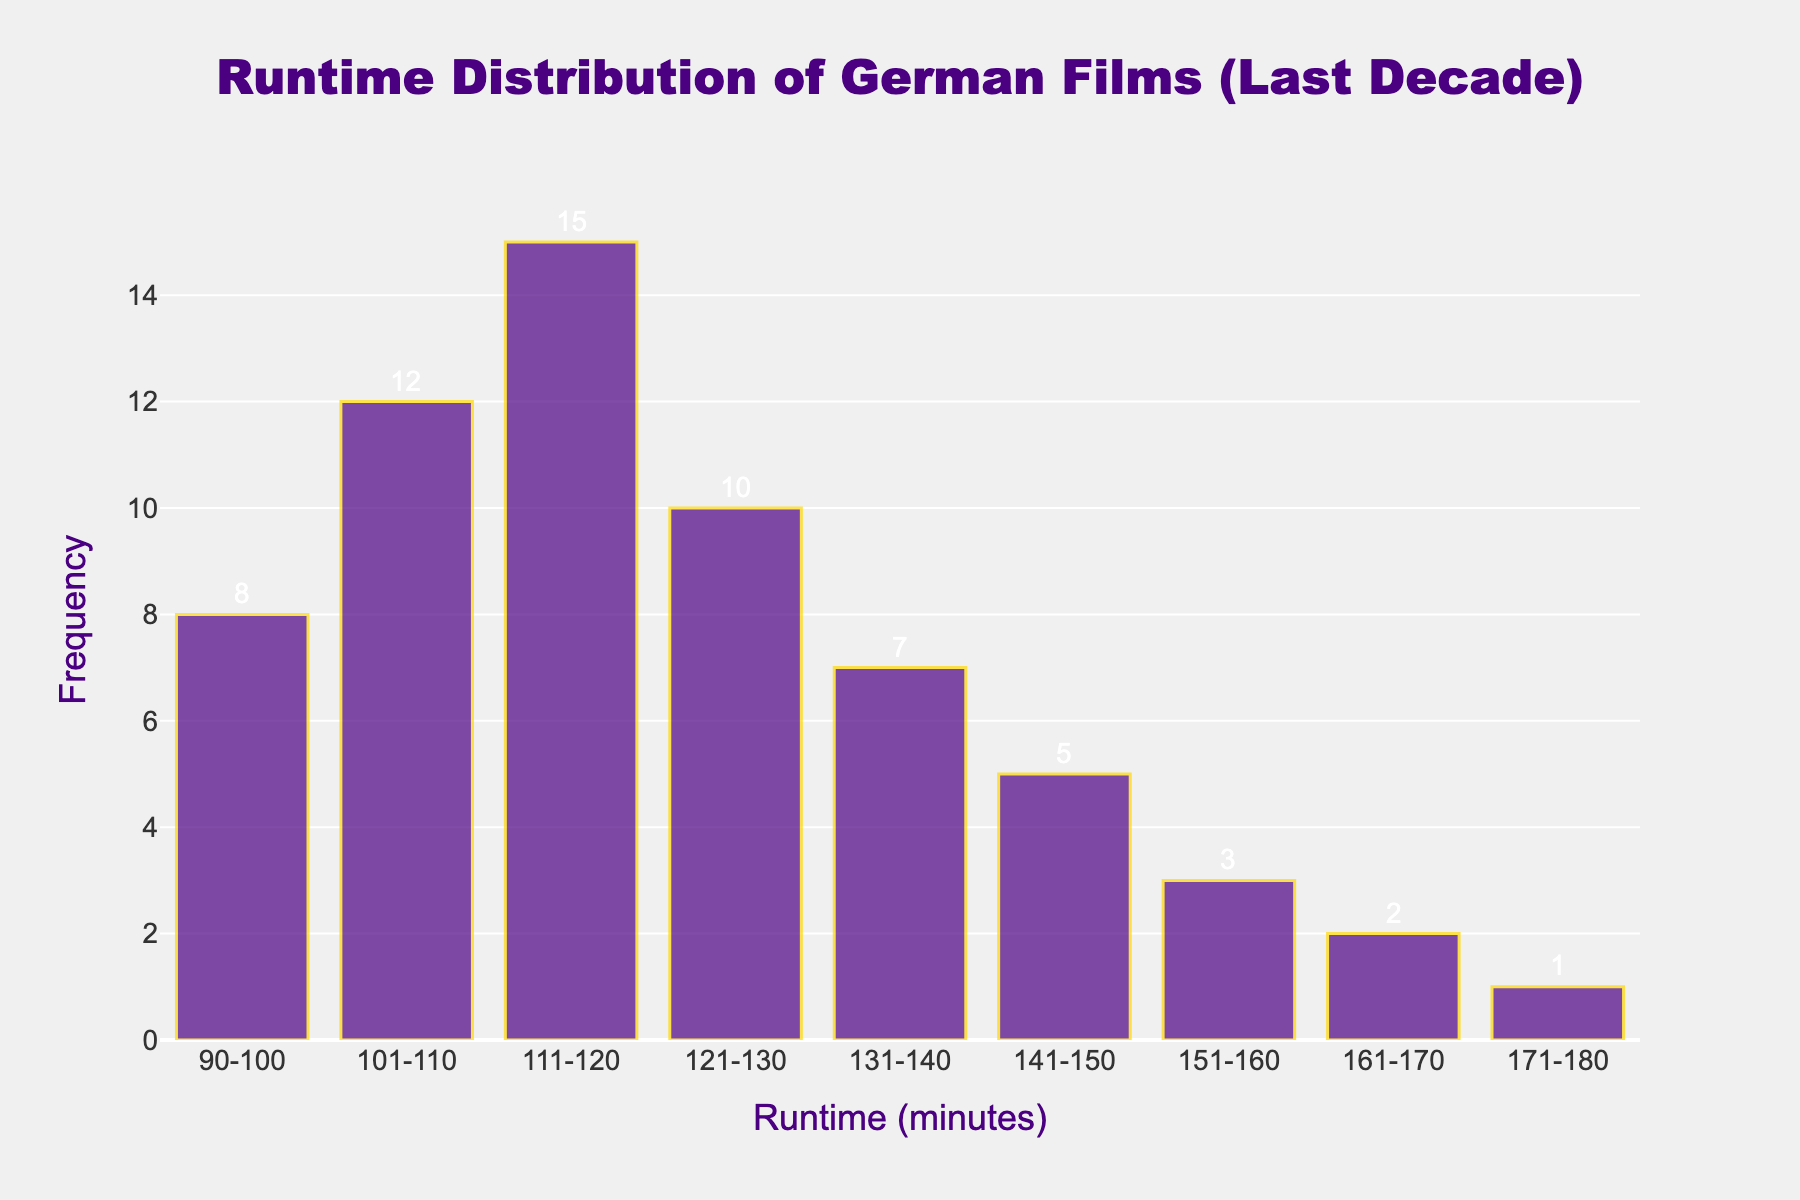What is the title of the histogram? The title of the histogram is displayed at the top center of the figure. It reads "Runtime Distribution of German Films (Last Decade)".
Answer: Runtime Distribution of German Films (Last Decade) What is the color of the bars in the histogram? The bars in the histogram are colored indigo.
Answer: Indigo What is the most frequent runtime range for German films? The highest bar in the histogram represents the most frequent runtime range. The bar with the highest frequency is in the 111-120 minutes range, which has a frequency of 15.
Answer: 111-120 minutes How many runtime ranges have a frequency of more than 10? By examining the bars, we find that the ranges 101-110 minutes (12) and 111-120 minutes (15) have frequencies greater than 10.
Answer: 2 What is the least frequent runtime range for German films? The bar with the lowest height represents the least frequent runtime range. The range 171-180 minutes has a frequency of 1.
Answer: 171-180 minutes What is the combined frequency of films with runtimes between 121 and 150 minutes? We add the frequencies for the ranges 121-130 (10), 131-140 (7), and 141-150 (5). The total is 10 + 7 + 5 = 22.
Answer: 22 Is the frequency of films with runtimes between 90 and 100 minutes greater than the frequency of those between 161 and 170 minutes? Comparing the bars for the ranges 90-100 minutes (8) and 161-170 minutes (2), 8 is greater than 2.
Answer: Yes What is the total number of German films considered in this histogram? Add the frequencies of all the runtime ranges: 8 + 12 + 15 + 10 + 7 + 5 + 3 + 2 + 1 = 63.
Answer: 63 Which runtime range has a frequency of 5? The bar corresponding to the range 141-150 minutes has a height indicating a frequency of 5.
Answer: 141-150 minutes Are there more films with runtimes between 101 and 130 minutes than those between 131 and 180 minutes? Sum the frequencies for 101-130 minutes (12 + 15 + 10 = 37) and compare to the total for 131-180 minutes (7 + 5 + 3 + 2 + 1 = 18). 37 is greater than 18.
Answer: Yes 